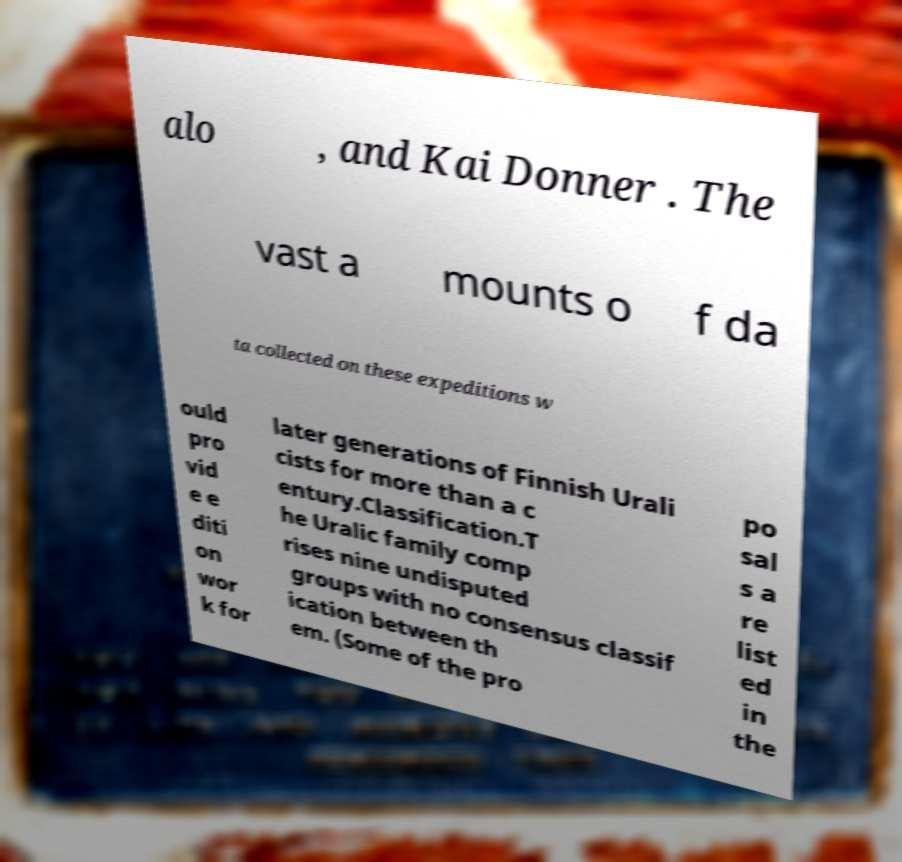I need the written content from this picture converted into text. Can you do that? alo , and Kai Donner . The vast a mounts o f da ta collected on these expeditions w ould pro vid e e diti on wor k for later generations of Finnish Urali cists for more than a c entury.Classification.T he Uralic family comp rises nine undisputed groups with no consensus classif ication between th em. (Some of the pro po sal s a re list ed in the 